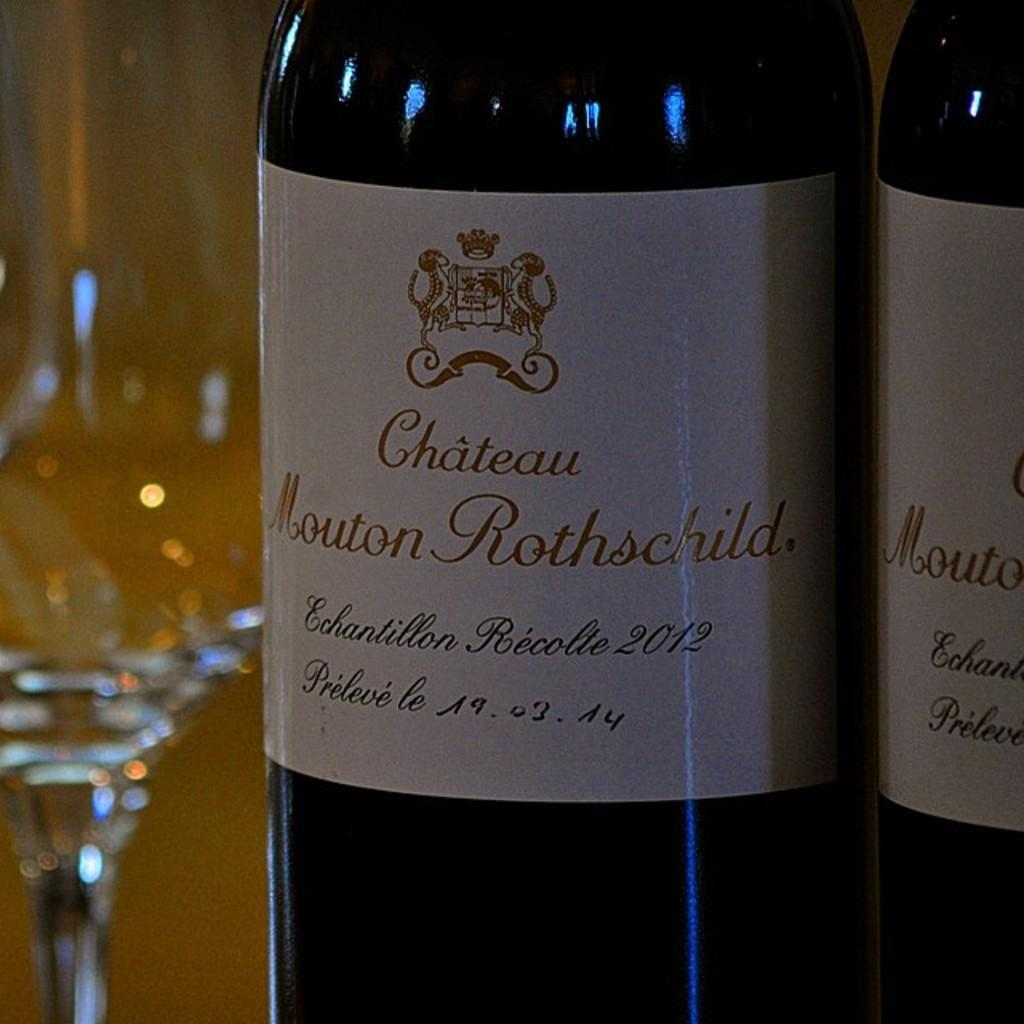<image>
Offer a succinct explanation of the picture presented. A bottle of wine from the Chateau Mouton Rothschild has a white label. 